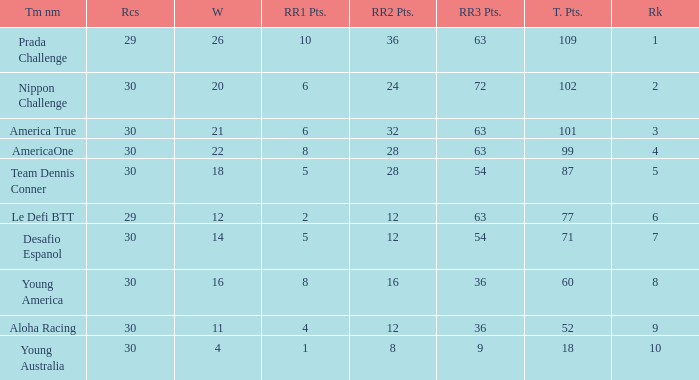Name the ranking for rr2 pts being 8 10.0. 